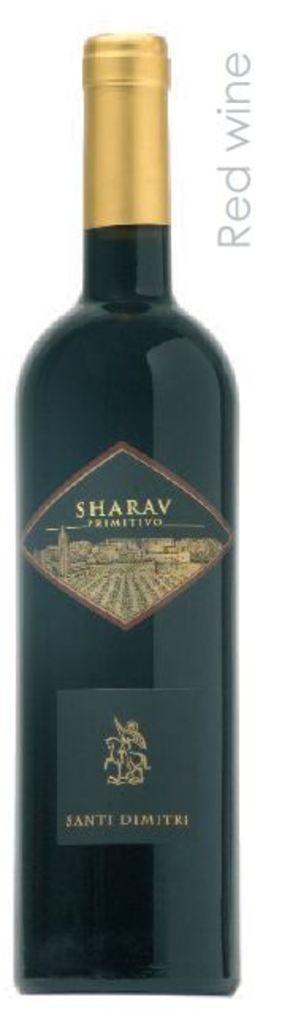<image>
Write a terse but informative summary of the picture. A bottle of wine bearing the word Sharav. 